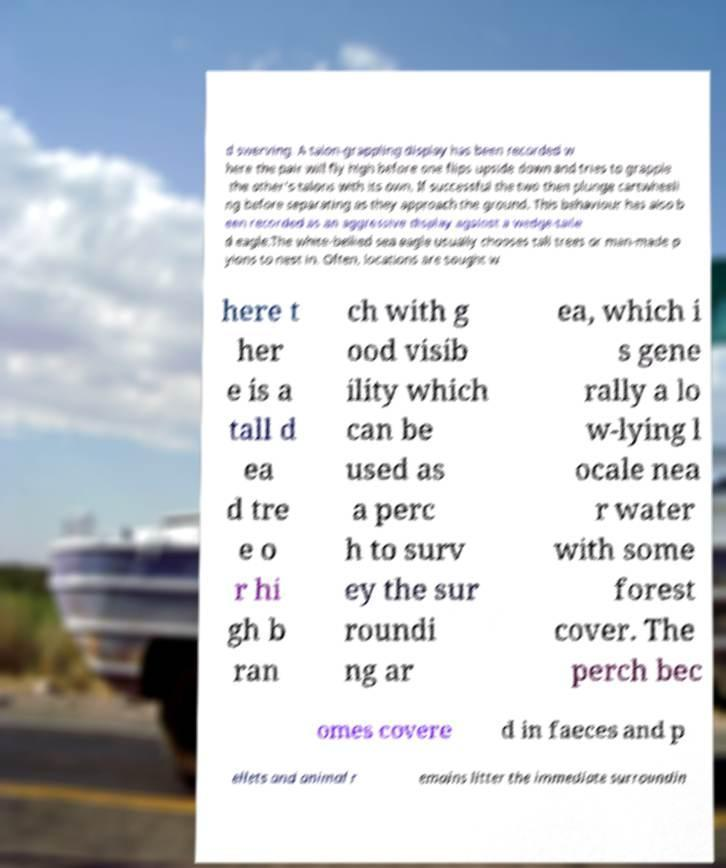What messages or text are displayed in this image? I need them in a readable, typed format. d swerving. A talon-grappling display has been recorded w here the pair will fly high before one flips upside down and tries to grapple the other's talons with its own. If successful the two then plunge cartwheeli ng before separating as they approach the ground. This behaviour has also b een recorded as an aggressive display against a wedge-taile d eagle.The white-bellied sea eagle usually chooses tall trees or man-made p ylons to nest in. Often, locations are sought w here t her e is a tall d ea d tre e o r hi gh b ran ch with g ood visib ility which can be used as a perc h to surv ey the sur roundi ng ar ea, which i s gene rally a lo w-lying l ocale nea r water with some forest cover. The perch bec omes covere d in faeces and p ellets and animal r emains litter the immediate surroundin 